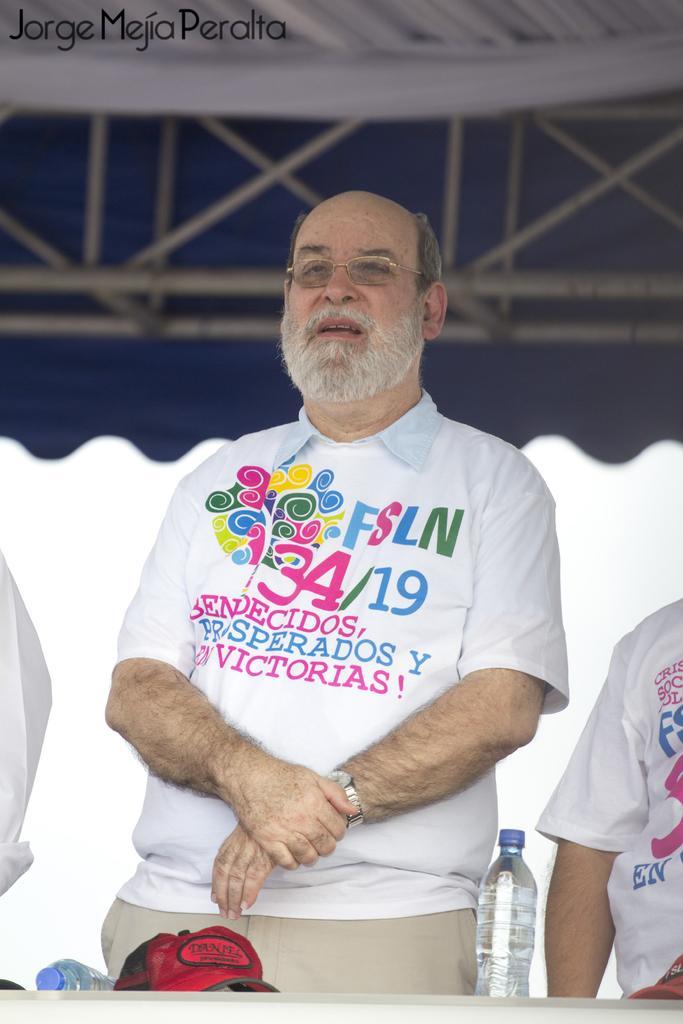Can you describe this image briefly? In this picture there are two persons standing. The man in the center is wearing a watch, spectacles and a white T-shirt with colorful text on it. In front of them there is a table and on it there are bottles and a red cap. To the top of the image there is roof. To the top left corner of the image there is text. 